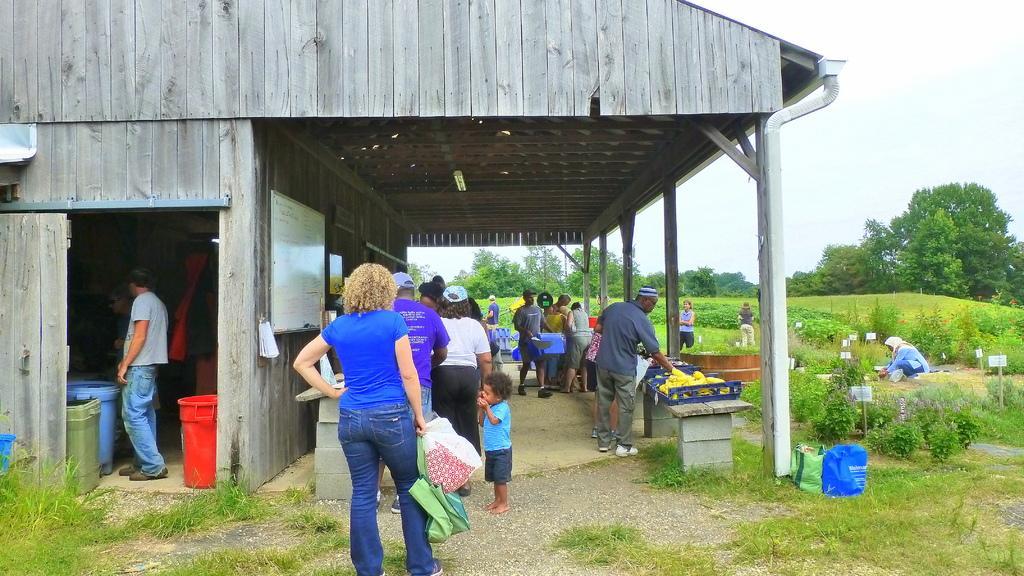Could you give a brief overview of what you see in this image? In this image in the center there is one house and there are some people who are walking and some of them are standing and carrying bags. On the right side there are some baskets, in that baskets there are some vegetables. On the left side there are some containers and some people are standing, on the right side there are some trees plants and some poles and one woman is sitting and doing something. At the bottom there is some grass and some bags. 